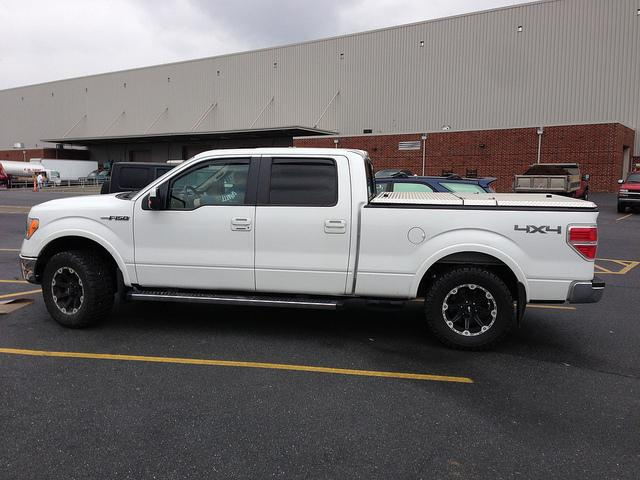What would the answer to the equation on the truck be if the x is replaced by a sign?

Choices:
A) 12
B) eight
C) zero
D) ten eight 